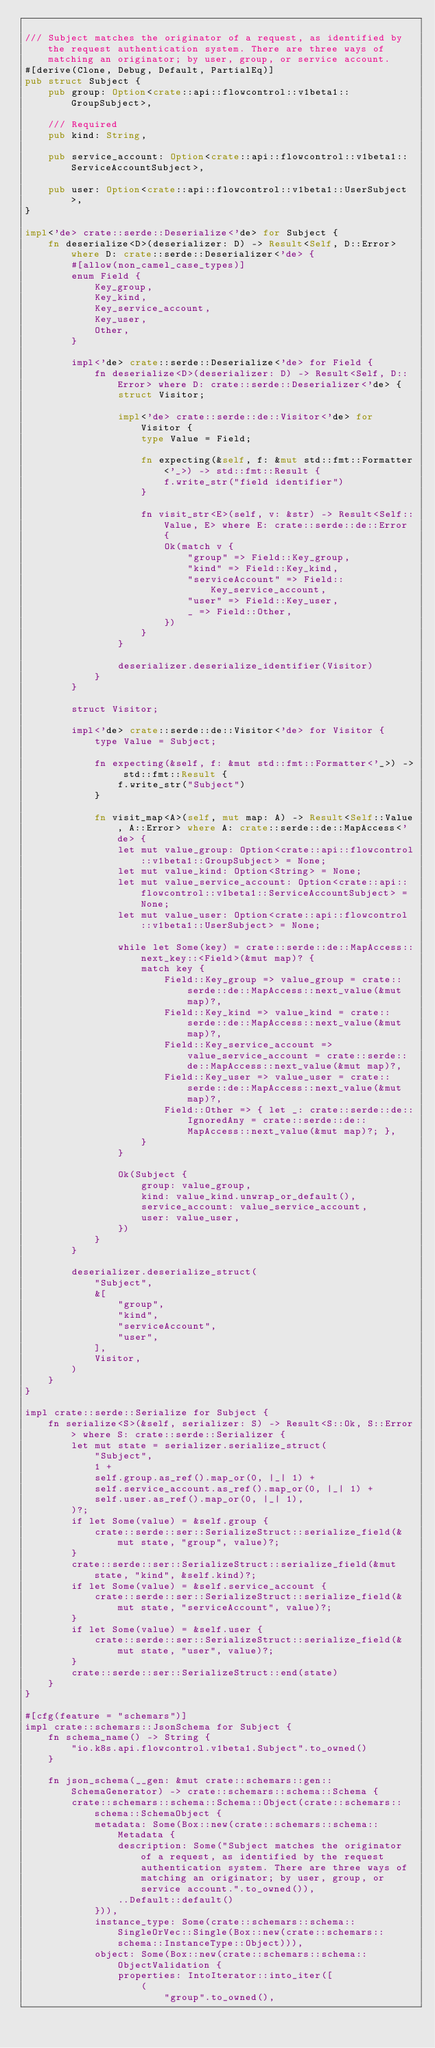<code> <loc_0><loc_0><loc_500><loc_500><_Rust_>
/// Subject matches the originator of a request, as identified by the request authentication system. There are three ways of matching an originator; by user, group, or service account.
#[derive(Clone, Debug, Default, PartialEq)]
pub struct Subject {
    pub group: Option<crate::api::flowcontrol::v1beta1::GroupSubject>,

    /// Required
    pub kind: String,

    pub service_account: Option<crate::api::flowcontrol::v1beta1::ServiceAccountSubject>,

    pub user: Option<crate::api::flowcontrol::v1beta1::UserSubject>,
}

impl<'de> crate::serde::Deserialize<'de> for Subject {
    fn deserialize<D>(deserializer: D) -> Result<Self, D::Error> where D: crate::serde::Deserializer<'de> {
        #[allow(non_camel_case_types)]
        enum Field {
            Key_group,
            Key_kind,
            Key_service_account,
            Key_user,
            Other,
        }

        impl<'de> crate::serde::Deserialize<'de> for Field {
            fn deserialize<D>(deserializer: D) -> Result<Self, D::Error> where D: crate::serde::Deserializer<'de> {
                struct Visitor;

                impl<'de> crate::serde::de::Visitor<'de> for Visitor {
                    type Value = Field;

                    fn expecting(&self, f: &mut std::fmt::Formatter<'_>) -> std::fmt::Result {
                        f.write_str("field identifier")
                    }

                    fn visit_str<E>(self, v: &str) -> Result<Self::Value, E> where E: crate::serde::de::Error {
                        Ok(match v {
                            "group" => Field::Key_group,
                            "kind" => Field::Key_kind,
                            "serviceAccount" => Field::Key_service_account,
                            "user" => Field::Key_user,
                            _ => Field::Other,
                        })
                    }
                }

                deserializer.deserialize_identifier(Visitor)
            }
        }

        struct Visitor;

        impl<'de> crate::serde::de::Visitor<'de> for Visitor {
            type Value = Subject;

            fn expecting(&self, f: &mut std::fmt::Formatter<'_>) -> std::fmt::Result {
                f.write_str("Subject")
            }

            fn visit_map<A>(self, mut map: A) -> Result<Self::Value, A::Error> where A: crate::serde::de::MapAccess<'de> {
                let mut value_group: Option<crate::api::flowcontrol::v1beta1::GroupSubject> = None;
                let mut value_kind: Option<String> = None;
                let mut value_service_account: Option<crate::api::flowcontrol::v1beta1::ServiceAccountSubject> = None;
                let mut value_user: Option<crate::api::flowcontrol::v1beta1::UserSubject> = None;

                while let Some(key) = crate::serde::de::MapAccess::next_key::<Field>(&mut map)? {
                    match key {
                        Field::Key_group => value_group = crate::serde::de::MapAccess::next_value(&mut map)?,
                        Field::Key_kind => value_kind = crate::serde::de::MapAccess::next_value(&mut map)?,
                        Field::Key_service_account => value_service_account = crate::serde::de::MapAccess::next_value(&mut map)?,
                        Field::Key_user => value_user = crate::serde::de::MapAccess::next_value(&mut map)?,
                        Field::Other => { let _: crate::serde::de::IgnoredAny = crate::serde::de::MapAccess::next_value(&mut map)?; },
                    }
                }

                Ok(Subject {
                    group: value_group,
                    kind: value_kind.unwrap_or_default(),
                    service_account: value_service_account,
                    user: value_user,
                })
            }
        }

        deserializer.deserialize_struct(
            "Subject",
            &[
                "group",
                "kind",
                "serviceAccount",
                "user",
            ],
            Visitor,
        )
    }
}

impl crate::serde::Serialize for Subject {
    fn serialize<S>(&self, serializer: S) -> Result<S::Ok, S::Error> where S: crate::serde::Serializer {
        let mut state = serializer.serialize_struct(
            "Subject",
            1 +
            self.group.as_ref().map_or(0, |_| 1) +
            self.service_account.as_ref().map_or(0, |_| 1) +
            self.user.as_ref().map_or(0, |_| 1),
        )?;
        if let Some(value) = &self.group {
            crate::serde::ser::SerializeStruct::serialize_field(&mut state, "group", value)?;
        }
        crate::serde::ser::SerializeStruct::serialize_field(&mut state, "kind", &self.kind)?;
        if let Some(value) = &self.service_account {
            crate::serde::ser::SerializeStruct::serialize_field(&mut state, "serviceAccount", value)?;
        }
        if let Some(value) = &self.user {
            crate::serde::ser::SerializeStruct::serialize_field(&mut state, "user", value)?;
        }
        crate::serde::ser::SerializeStruct::end(state)
    }
}

#[cfg(feature = "schemars")]
impl crate::schemars::JsonSchema for Subject {
    fn schema_name() -> String {
        "io.k8s.api.flowcontrol.v1beta1.Subject".to_owned()
    }

    fn json_schema(__gen: &mut crate::schemars::gen::SchemaGenerator) -> crate::schemars::schema::Schema {
        crate::schemars::schema::Schema::Object(crate::schemars::schema::SchemaObject {
            metadata: Some(Box::new(crate::schemars::schema::Metadata {
                description: Some("Subject matches the originator of a request, as identified by the request authentication system. There are three ways of matching an originator; by user, group, or service account.".to_owned()),
                ..Default::default()
            })),
            instance_type: Some(crate::schemars::schema::SingleOrVec::Single(Box::new(crate::schemars::schema::InstanceType::Object))),
            object: Some(Box::new(crate::schemars::schema::ObjectValidation {
                properties: IntoIterator::into_iter([
                    (
                        "group".to_owned(),</code> 